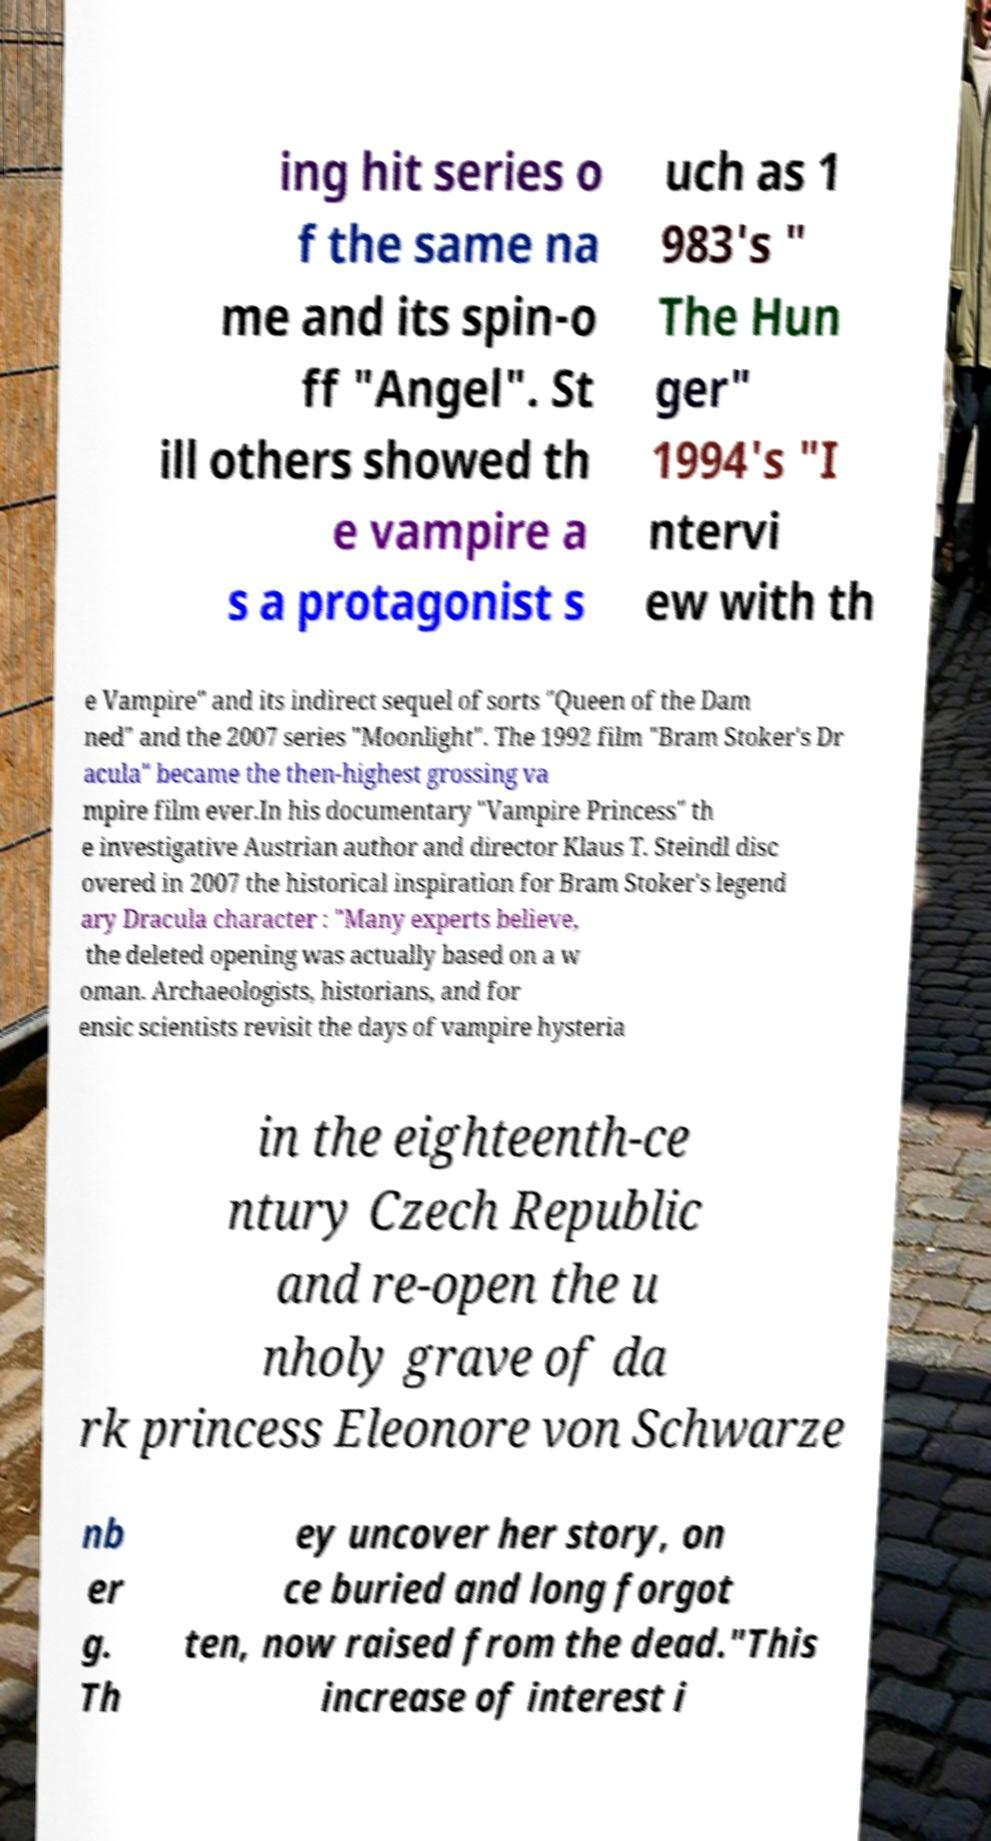Please identify and transcribe the text found in this image. ing hit series o f the same na me and its spin-o ff "Angel". St ill others showed th e vampire a s a protagonist s uch as 1 983's " The Hun ger" 1994's "I ntervi ew with th e Vampire" and its indirect sequel of sorts "Queen of the Dam ned" and the 2007 series "Moonlight". The 1992 film "Bram Stoker's Dr acula" became the then-highest grossing va mpire film ever.In his documentary "Vampire Princess" th e investigative Austrian author and director Klaus T. Steindl disc overed in 2007 the historical inspiration for Bram Stoker's legend ary Dracula character : "Many experts believe, the deleted opening was actually based on a w oman. Archaeologists, historians, and for ensic scientists revisit the days of vampire hysteria in the eighteenth-ce ntury Czech Republic and re-open the u nholy grave of da rk princess Eleonore von Schwarze nb er g. Th ey uncover her story, on ce buried and long forgot ten, now raised from the dead."This increase of interest i 